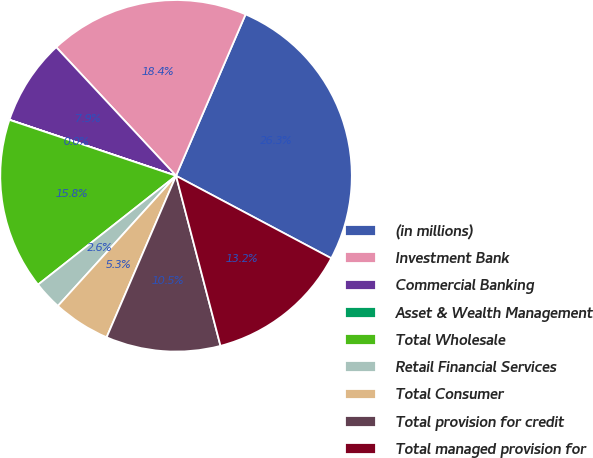Convert chart. <chart><loc_0><loc_0><loc_500><loc_500><pie_chart><fcel>(in millions)<fcel>Investment Bank<fcel>Commercial Banking<fcel>Asset & Wealth Management<fcel>Total Wholesale<fcel>Retail Financial Services<fcel>Total Consumer<fcel>Total provision for credit<fcel>Total managed provision for<nl><fcel>26.3%<fcel>18.41%<fcel>7.9%<fcel>0.01%<fcel>15.78%<fcel>2.64%<fcel>5.27%<fcel>10.53%<fcel>13.16%<nl></chart> 